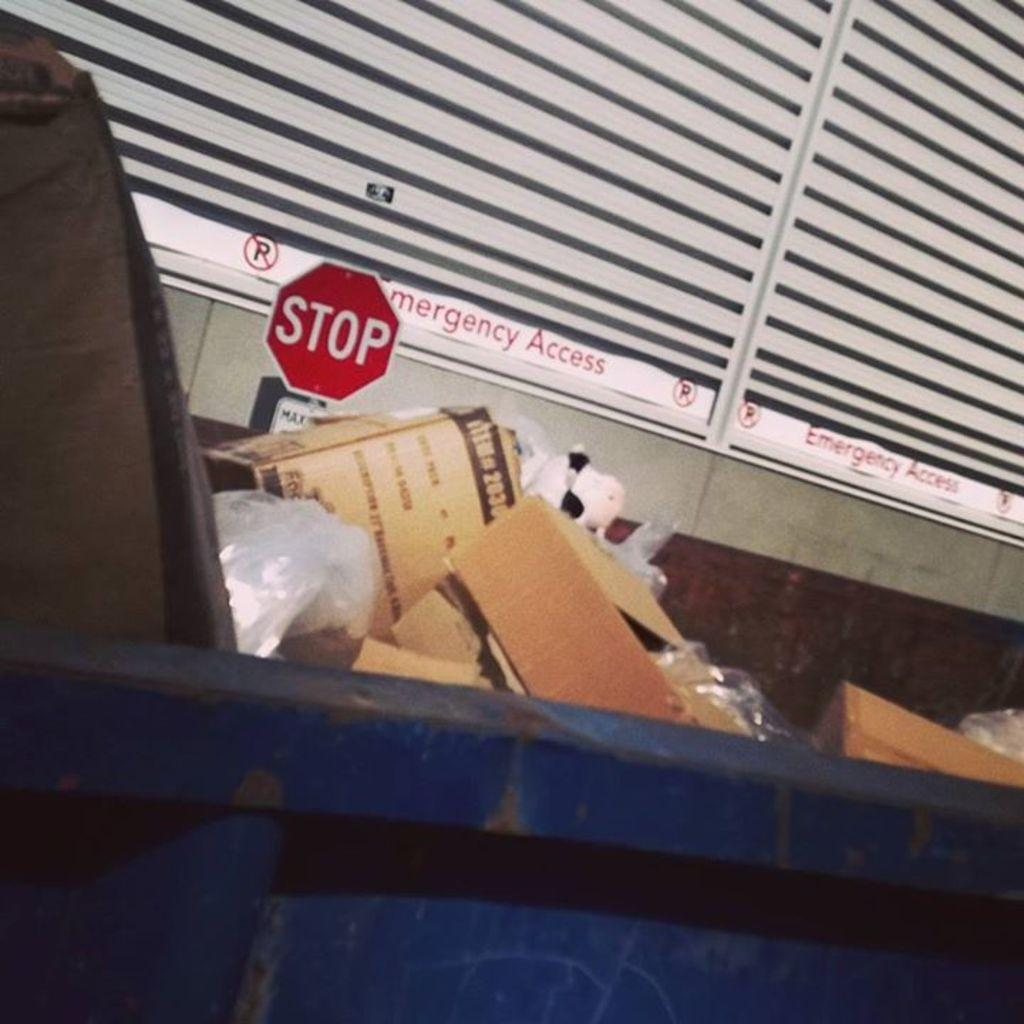What object is present in the image for disposing of waste? There is a trash can in the image for disposing of waste. What is inside the trash can? There is waste in the trash can. What can be seen in the background of the image? There is a stop board and windows visible in the background of the image. What type of lace can be seen on the stop board in the image? There is no lace present on the stop board in the image. What type of competition is taking place in the image? There is no competition taking place in the image. 